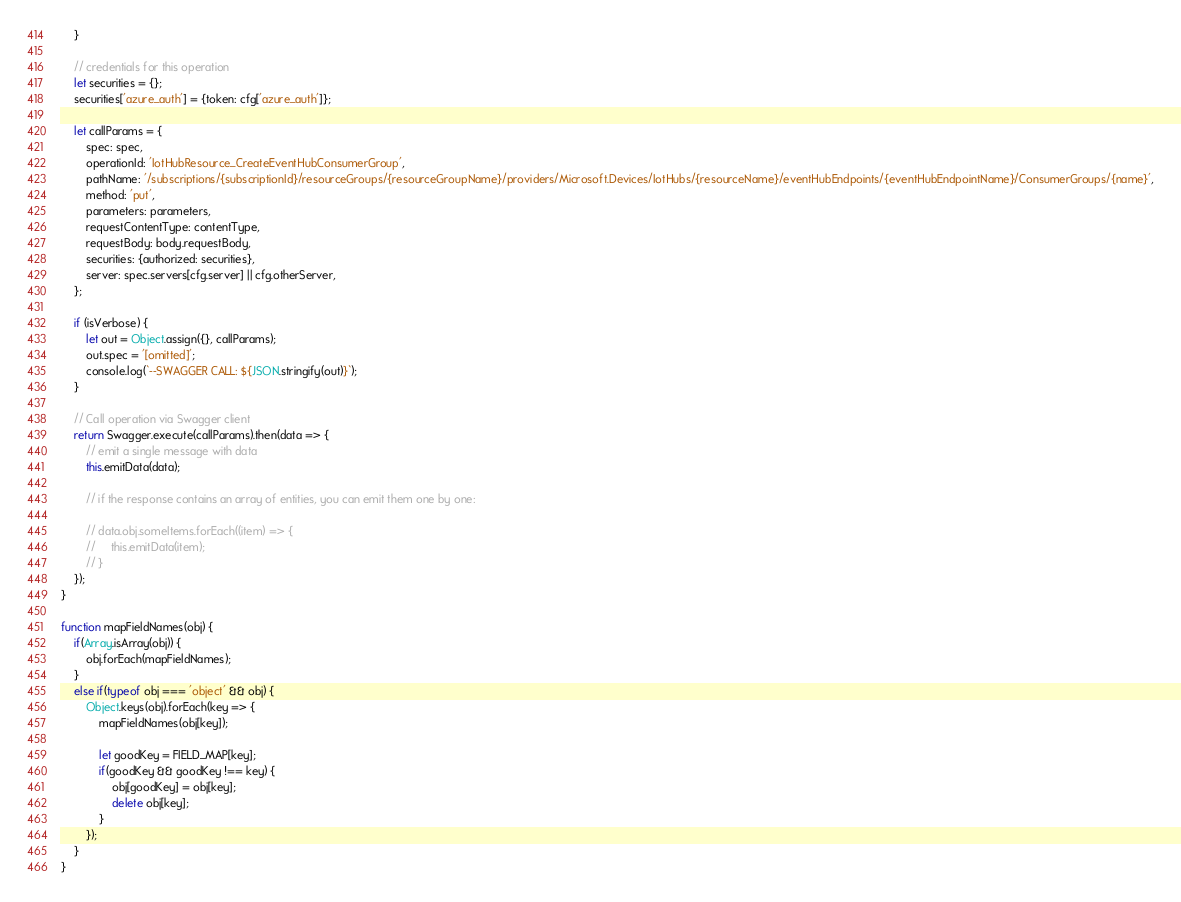Convert code to text. <code><loc_0><loc_0><loc_500><loc_500><_JavaScript_>    }

    // credentials for this operation
    let securities = {};
    securities['azure_auth'] = {token: cfg['azure_auth']};

    let callParams = {
        spec: spec,
        operationId: 'IotHubResource_CreateEventHubConsumerGroup',
        pathName: '/subscriptions/{subscriptionId}/resourceGroups/{resourceGroupName}/providers/Microsoft.Devices/IotHubs/{resourceName}/eventHubEndpoints/{eventHubEndpointName}/ConsumerGroups/{name}',
        method: 'put',
        parameters: parameters,
        requestContentType: contentType,
        requestBody: body.requestBody,
        securities: {authorized: securities},
        server: spec.servers[cfg.server] || cfg.otherServer,
    };

    if (isVerbose) {
        let out = Object.assign({}, callParams);
        out.spec = '[omitted]';
        console.log(`--SWAGGER CALL: ${JSON.stringify(out)}`);
    }

    // Call operation via Swagger client
    return Swagger.execute(callParams).then(data => {
        // emit a single message with data
        this.emitData(data);

        // if the response contains an array of entities, you can emit them one by one:

        // data.obj.someItems.forEach((item) => {
        //     this.emitData(item);
        // }
    });
}

function mapFieldNames(obj) {
    if(Array.isArray(obj)) {
        obj.forEach(mapFieldNames);
    }
    else if(typeof obj === 'object' && obj) {
        Object.keys(obj).forEach(key => {
            mapFieldNames(obj[key]);

            let goodKey = FIELD_MAP[key];
            if(goodKey && goodKey !== key) {
                obj[goodKey] = obj[key];
                delete obj[key];
            }
        });
    }
}</code> 